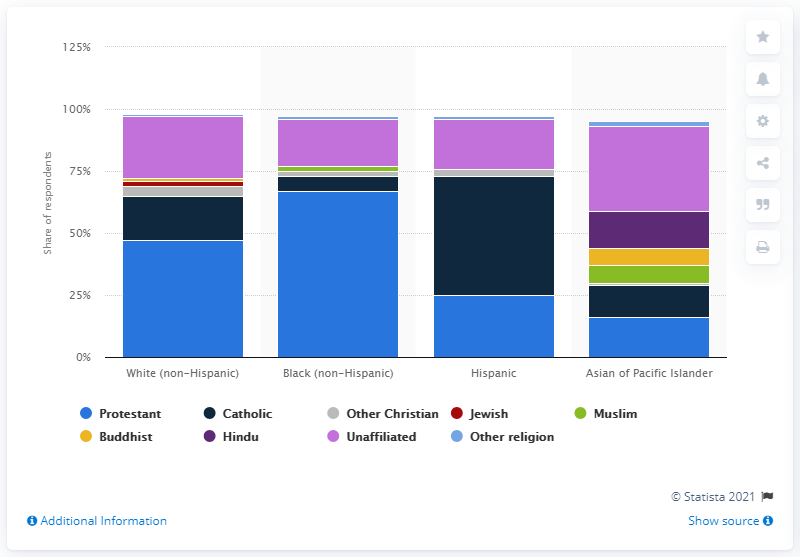Identify some key points in this picture. According to a recent survey, 15 percent of Asian or Pacific Islanders identified themselves as Hindu. 